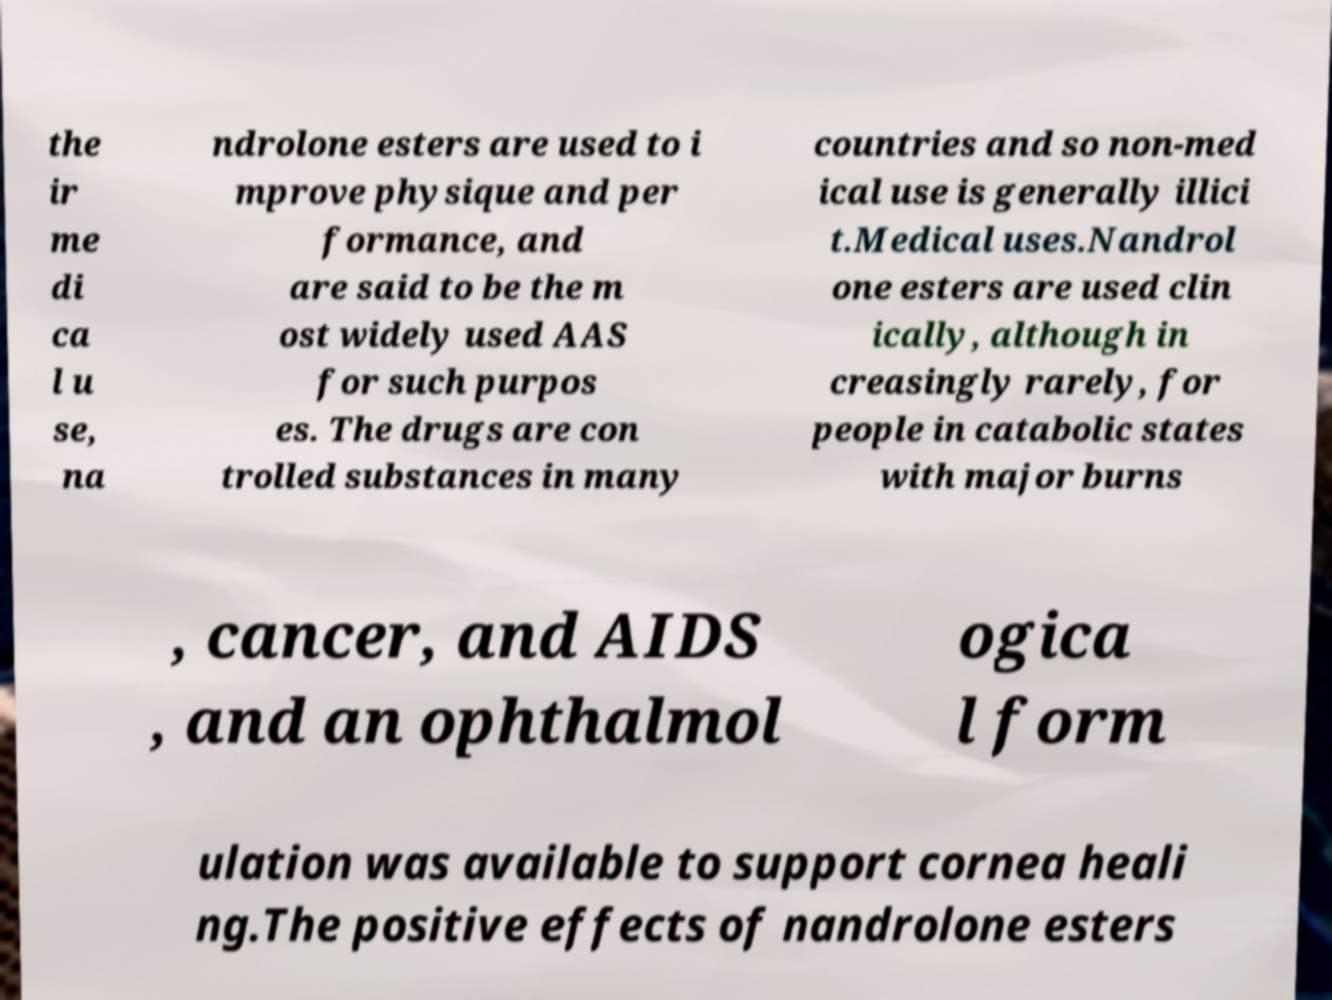For documentation purposes, I need the text within this image transcribed. Could you provide that? the ir me di ca l u se, na ndrolone esters are used to i mprove physique and per formance, and are said to be the m ost widely used AAS for such purpos es. The drugs are con trolled substances in many countries and so non-med ical use is generally illici t.Medical uses.Nandrol one esters are used clin ically, although in creasingly rarely, for people in catabolic states with major burns , cancer, and AIDS , and an ophthalmol ogica l form ulation was available to support cornea heali ng.The positive effects of nandrolone esters 